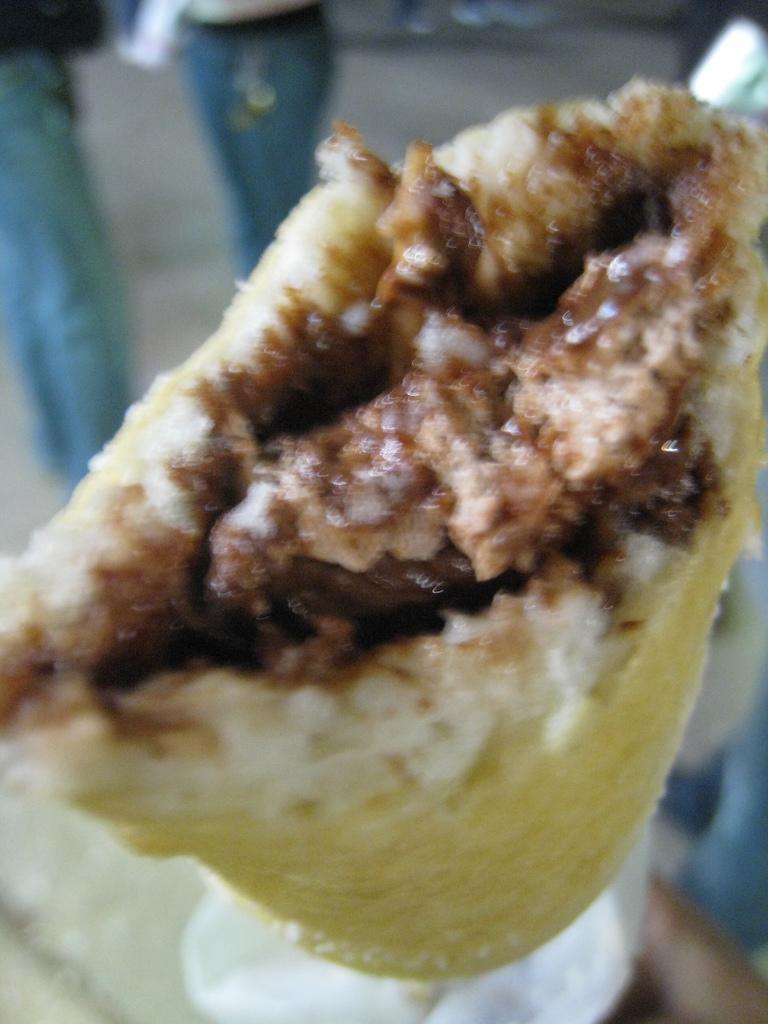Please provide a concise description of this image. In this picture we can see the food. Behind the food, there is a blurred background. In the top left corner of the image, those are looking like legs of people. 